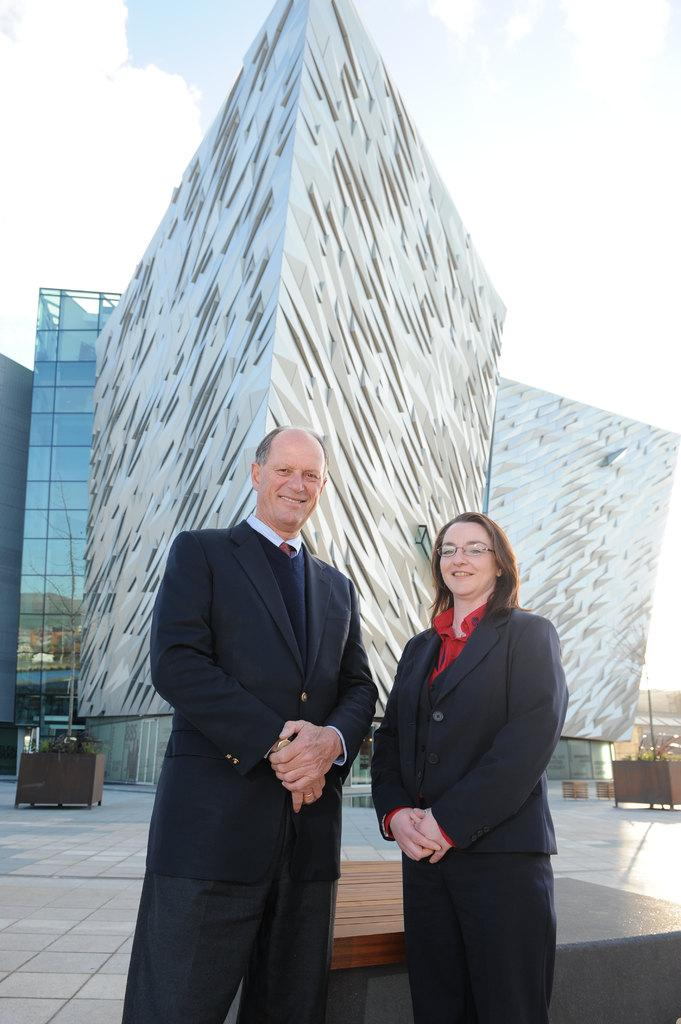How many people are in the image? There are two people in the image: a man and a woman. What can be seen in the background of the image? Buildings and wooden objects are visible in the background. What is visible at the top of the image? The sky is visible at the top of the image. What type of horn can be heard in the image? There is no horn present in the image, and therefore no sound can be heard. 